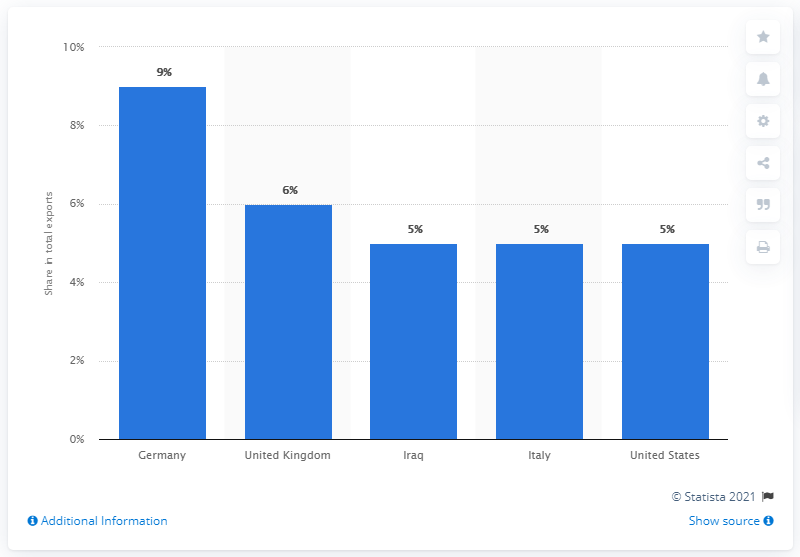List a handful of essential elements in this visual. In 2019, Germany was the leading export partner of Turkey. 